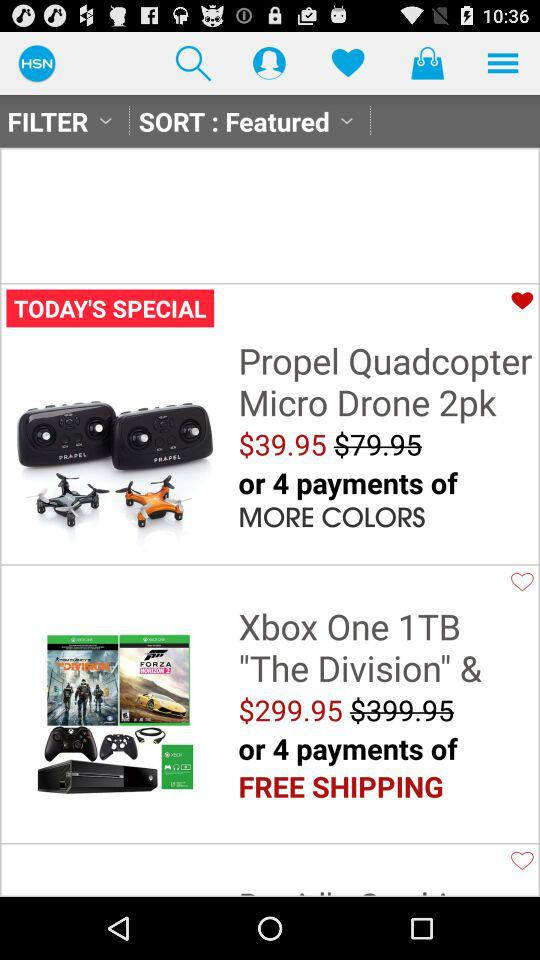What is the price of the "Xbox One 1TB"? The price of the "Xbox One 1TB" is $299.95. 